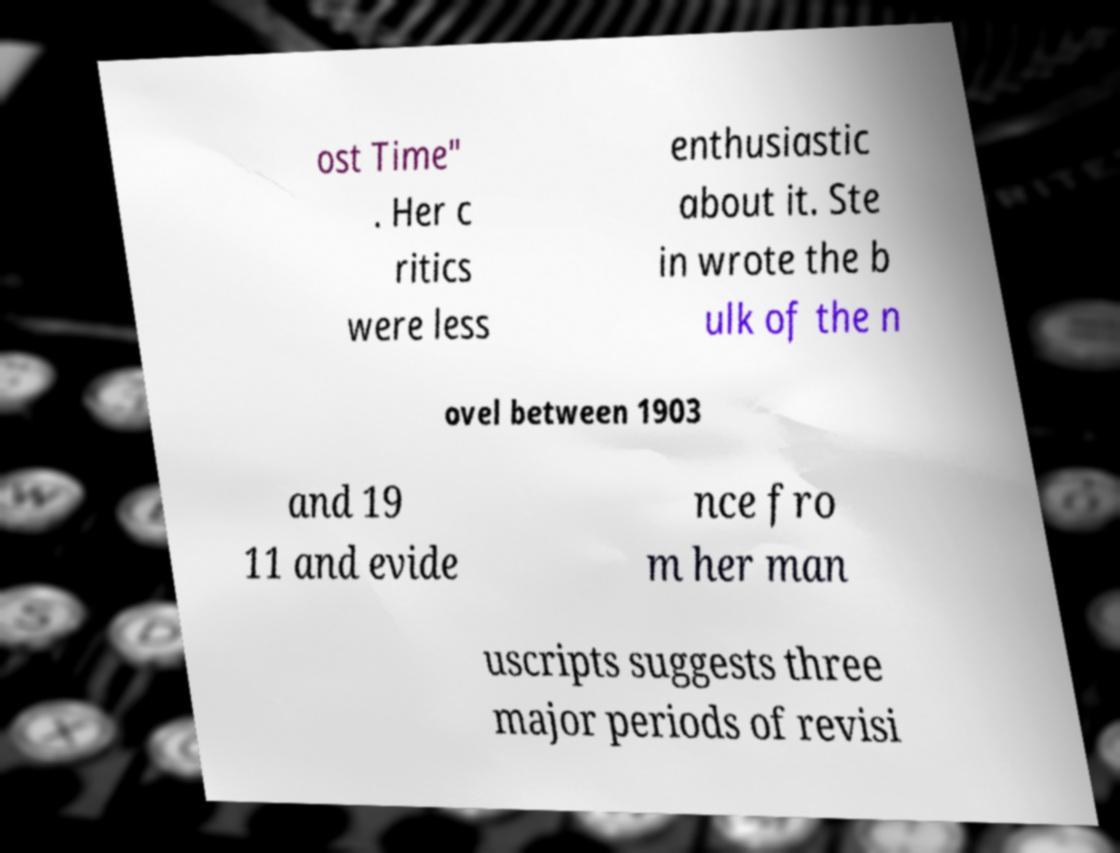There's text embedded in this image that I need extracted. Can you transcribe it verbatim? ost Time" . Her c ritics were less enthusiastic about it. Ste in wrote the b ulk of the n ovel between 1903 and 19 11 and evide nce fro m her man uscripts suggests three major periods of revisi 